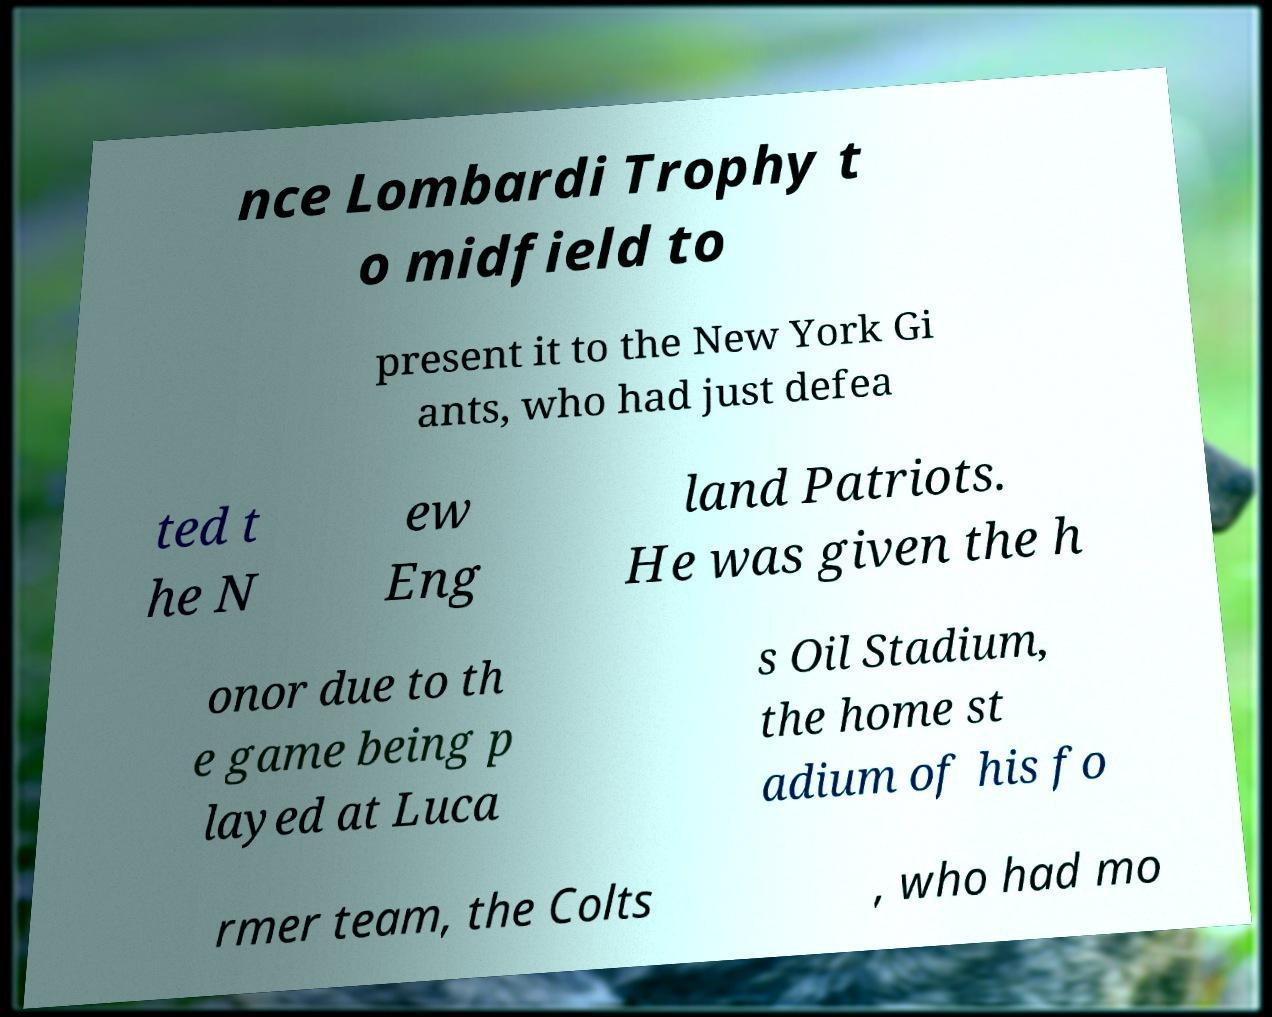For documentation purposes, I need the text within this image transcribed. Could you provide that? nce Lombardi Trophy t o midfield to present it to the New York Gi ants, who had just defea ted t he N ew Eng land Patriots. He was given the h onor due to th e game being p layed at Luca s Oil Stadium, the home st adium of his fo rmer team, the Colts , who had mo 